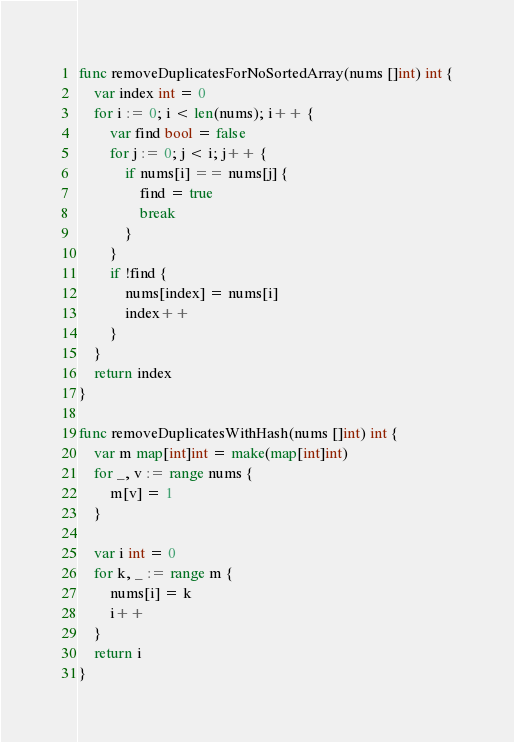Convert code to text. <code><loc_0><loc_0><loc_500><loc_500><_Go_>func removeDuplicatesForNoSortedArray(nums []int) int {
	var index int = 0
	for i := 0; i < len(nums); i++ {
		var find bool = false
		for j := 0; j < i; j++ {
			if nums[i] == nums[j] {
				find = true
				break
			}
		}
		if !find {
			nums[index] = nums[i]
			index++
		}
	}
	return index
}

func removeDuplicatesWithHash(nums []int) int {
	var m map[int]int = make(map[int]int)
	for _, v := range nums {
		m[v] = 1
	}

	var i int = 0
	for k, _ := range m {
		nums[i] = k
		i++
	}
	return i
}
</code> 